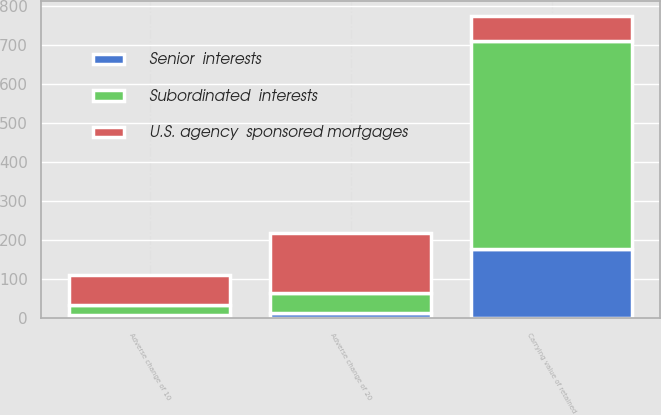Convert chart. <chart><loc_0><loc_0><loc_500><loc_500><stacked_bar_chart><ecel><fcel>Carrying value of retained<fcel>Adverse change of 10<fcel>Adverse change of 20<nl><fcel>U.S. agency  sponsored mortgages<fcel>64<fcel>79<fcel>155<nl><fcel>Senior  interests<fcel>179<fcel>8<fcel>15<nl><fcel>Subordinated  interests<fcel>533<fcel>25<fcel>49<nl></chart> 